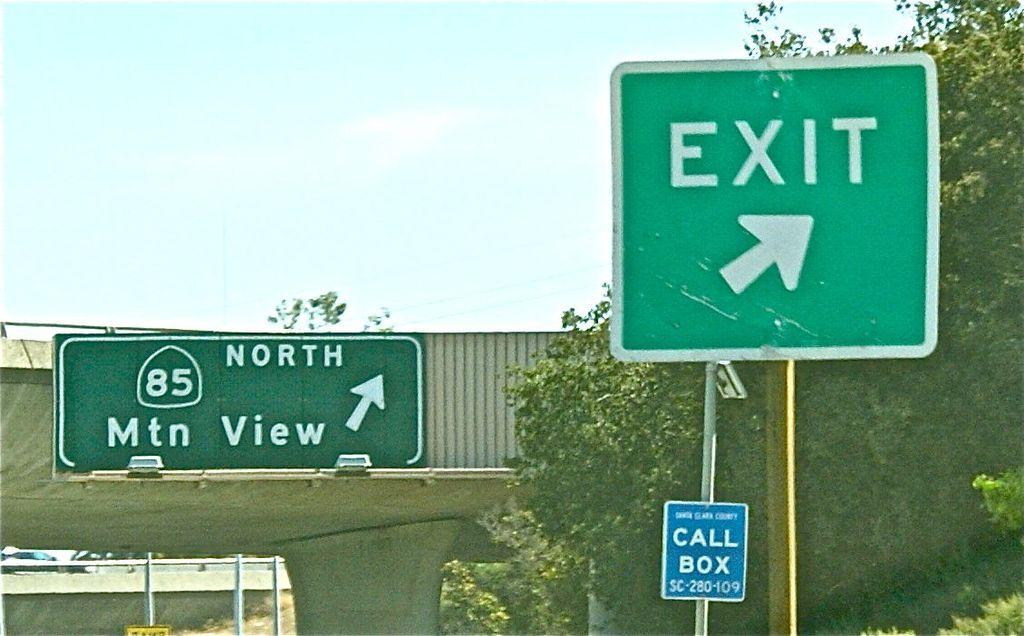<image>
Give a short and clear explanation of the subsequent image. A street sign on route 85 depicts an exit for Mtn View. 